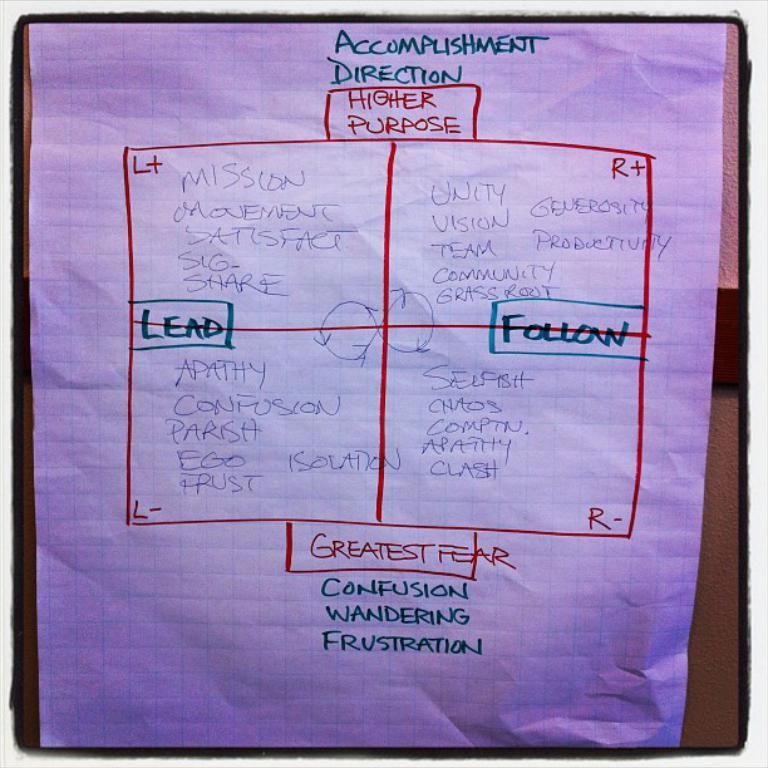<image>
Create a compact narrative representing the image presented. A piece of paper has the words Accomplishment Direction at the top. 